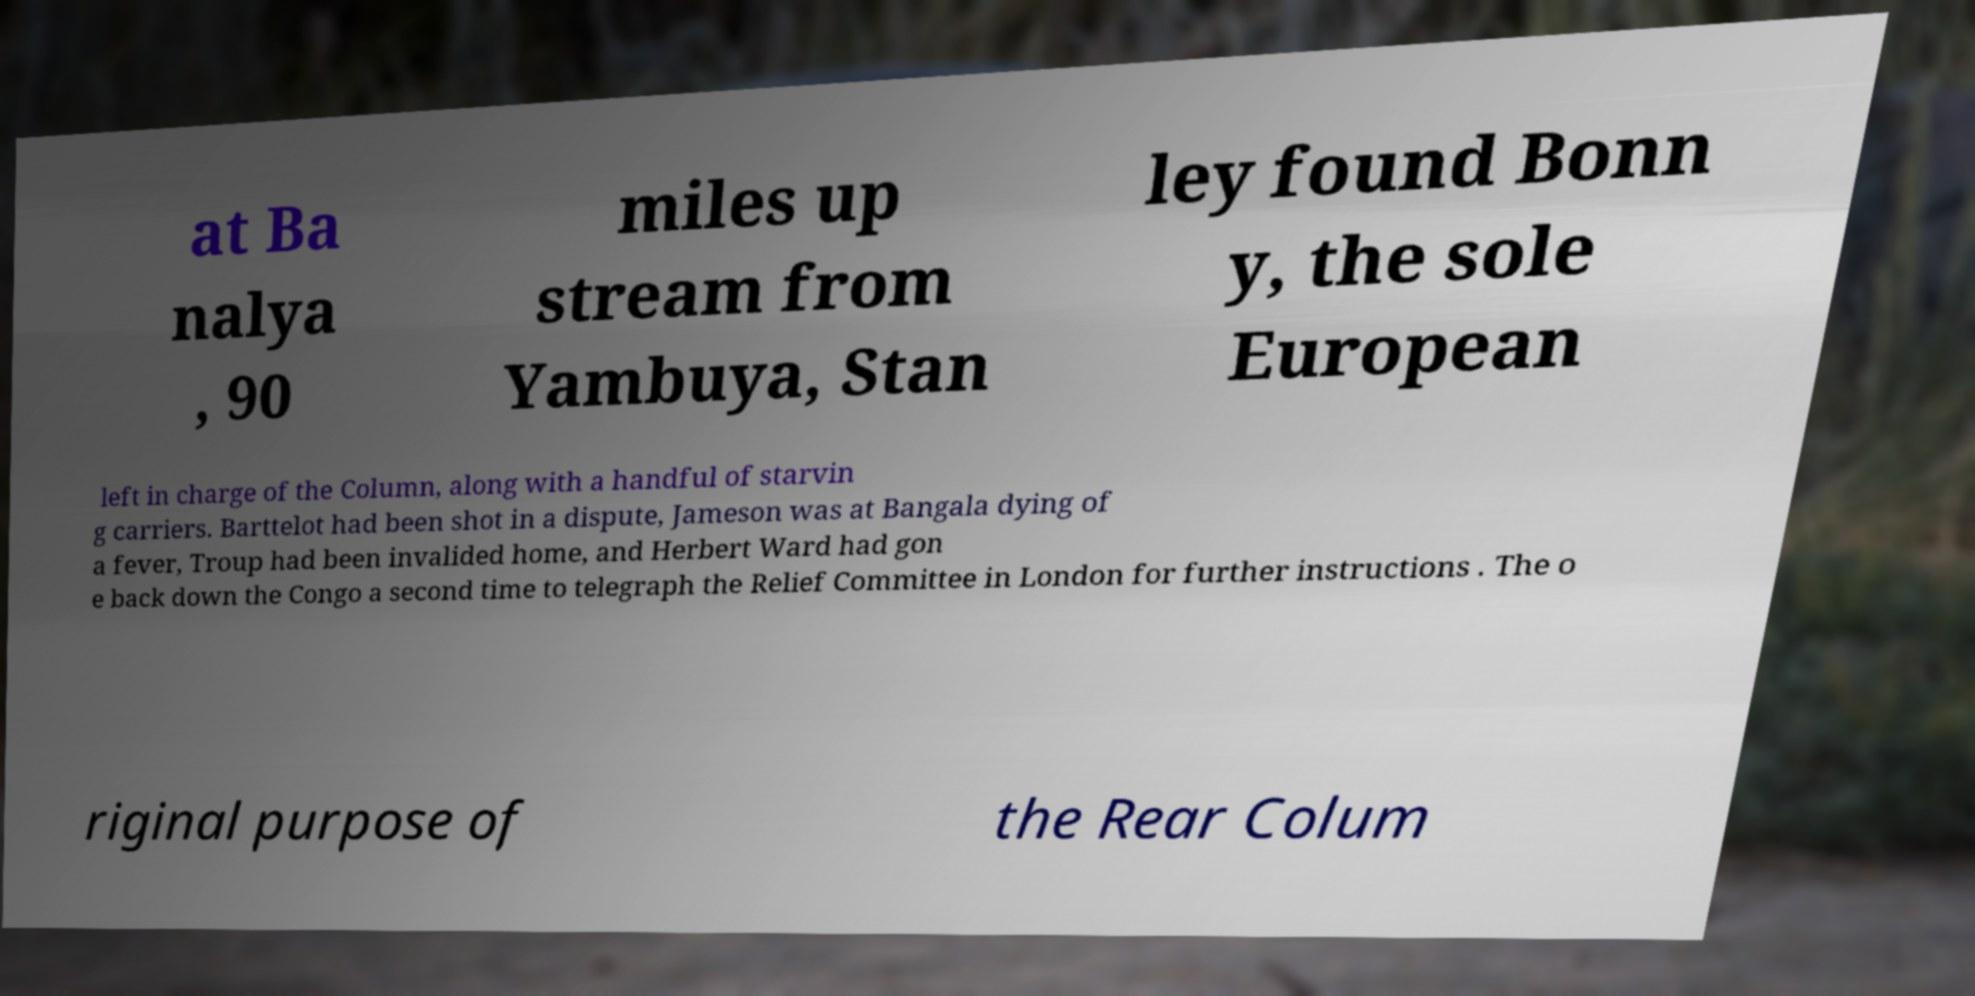There's text embedded in this image that I need extracted. Can you transcribe it verbatim? at Ba nalya , 90 miles up stream from Yambuya, Stan ley found Bonn y, the sole European left in charge of the Column, along with a handful of starvin g carriers. Barttelot had been shot in a dispute, Jameson was at Bangala dying of a fever, Troup had been invalided home, and Herbert Ward had gon e back down the Congo a second time to telegraph the Relief Committee in London for further instructions . The o riginal purpose of the Rear Colum 